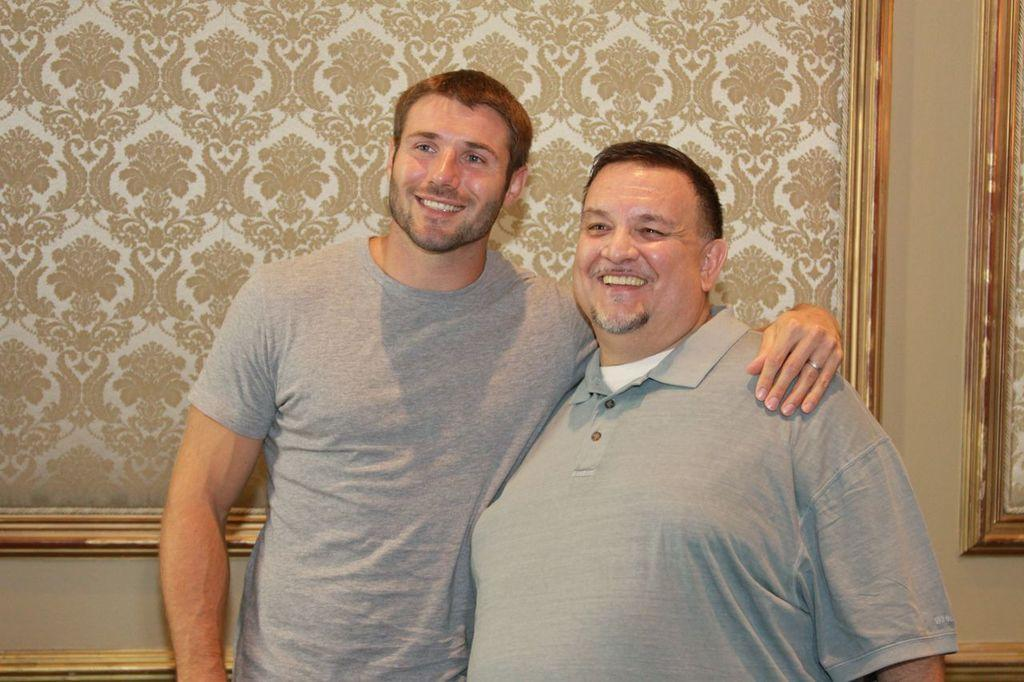How many people are in the image? There are two people in the image. What are the people doing in the image? The people are standing in the image. What expressions do the people have in the image? The people are smiling in the image. What can be seen on the wall behind the people? There are designs on the wall behind the people. What type of grain is being harvested by the dogs in the image? There are no dogs or grain present in the image; it features two people standing and smiling. 